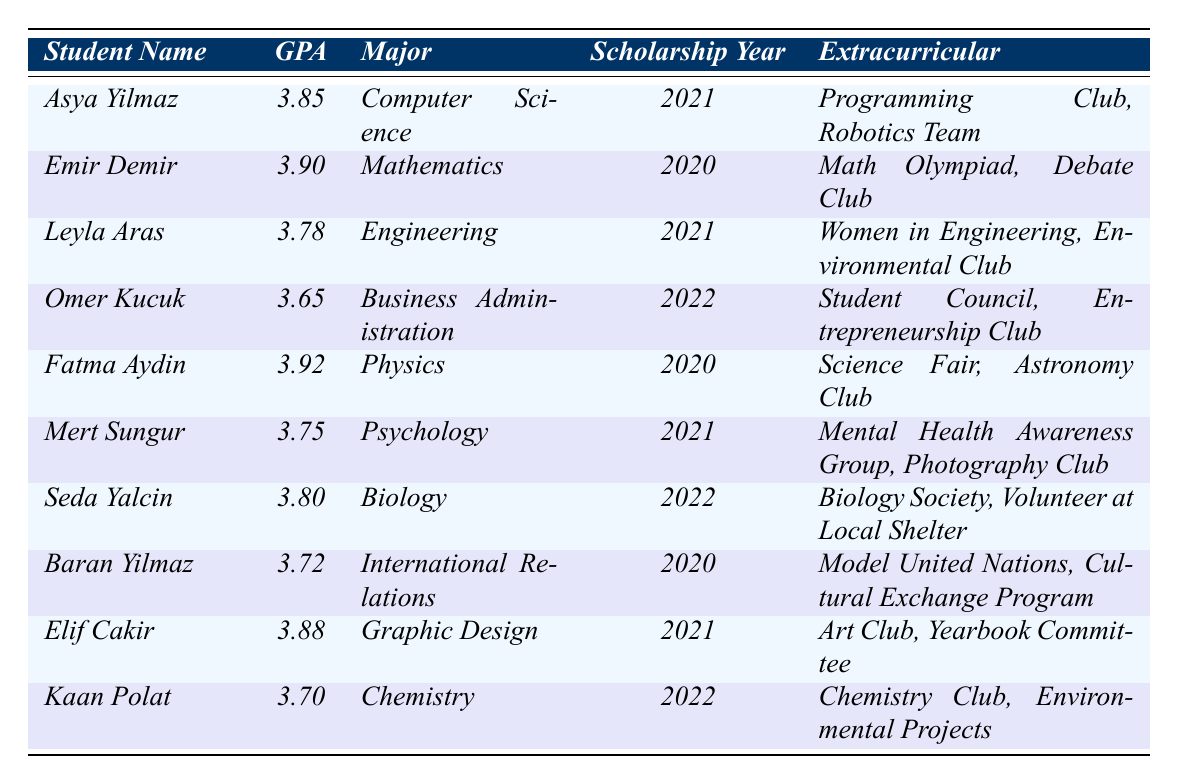What is the highest GPA among the scholarship students? By examining the GPA column in the table, I see that Fatma Aydin has the highest GPA of 3.92.
Answer: 3.92 Which student has a major in Chemistry? Looking at the Major column, I find that Kaan Polat is the only student listed with the major Chemistry.
Answer: Kaan Polat How many students have a GPA above 3.80? I count the students with GPAs greater than 3.80: Asya Yilmaz (3.85), Emir Demir (3.90), Fatma Aydin (3.92), and Elif Cakir (3.88), totaling four students.
Answer: 4 Is Leyla Aras involved in any extracurricular activities related to environmental issues? Since Leyla Aras is part of the Environmental Club, this confirms her involvement in extracurricular activities related to environmental issues.
Answer: Yes What is the average GPA of students who received the scholarship in 2021? The GPAs of the students who received the scholarship in 2021 are 3.85 (Asya Yilmaz), 3.78 (Leyla Aras), and 3.75 (Mert Sungur). Adding them gives 3.85 + 3.78 + 3.75 = 11.38, and then dividing by 3 gives an average GPA of approximately 3.79.
Answer: 3.79 Which major has the lowest GPA among the students listed? By reviewing the GPAs, Omer Kucuk has the lowest GPA of 3.65, and his major is Business Administration.
Answer: Business Administration Are there any students with GPAs below 3.70? Looking at the GPA values, Omer Kucuk (3.65) has a GPA below 3.70, confirming that yes, there are students below that threshold.
Answer: Yes What extracurricular activities are listed for the student with the highest GPA? Fatma Aydin, who has the highest GPA of 3.92, is involved in the Science Fair and Astronomy Club.
Answer: Science Fair, Astronomy Club How many students major in the field of science (Biology, Physics, Chemistry, or Computer Science)? The students majoring in science-related fields are Asya Yilmaz (Computer Science), Fatma Aydin (Physics), Seda Yalcin (Biology), and Kaan Polat (Chemistry), totaling four students.
Answer: 4 Who are the students that received their scholarships in 2020? By checking the Scholarship Year column, I find that Emir Demir, Fatma Aydin, and Baran Yilmaz received their scholarships in 2020.
Answer: Emir Demir, Fatma Aydin, Baran Yilmaz 